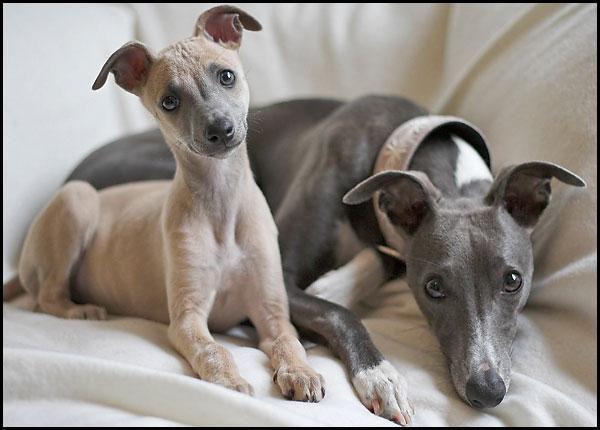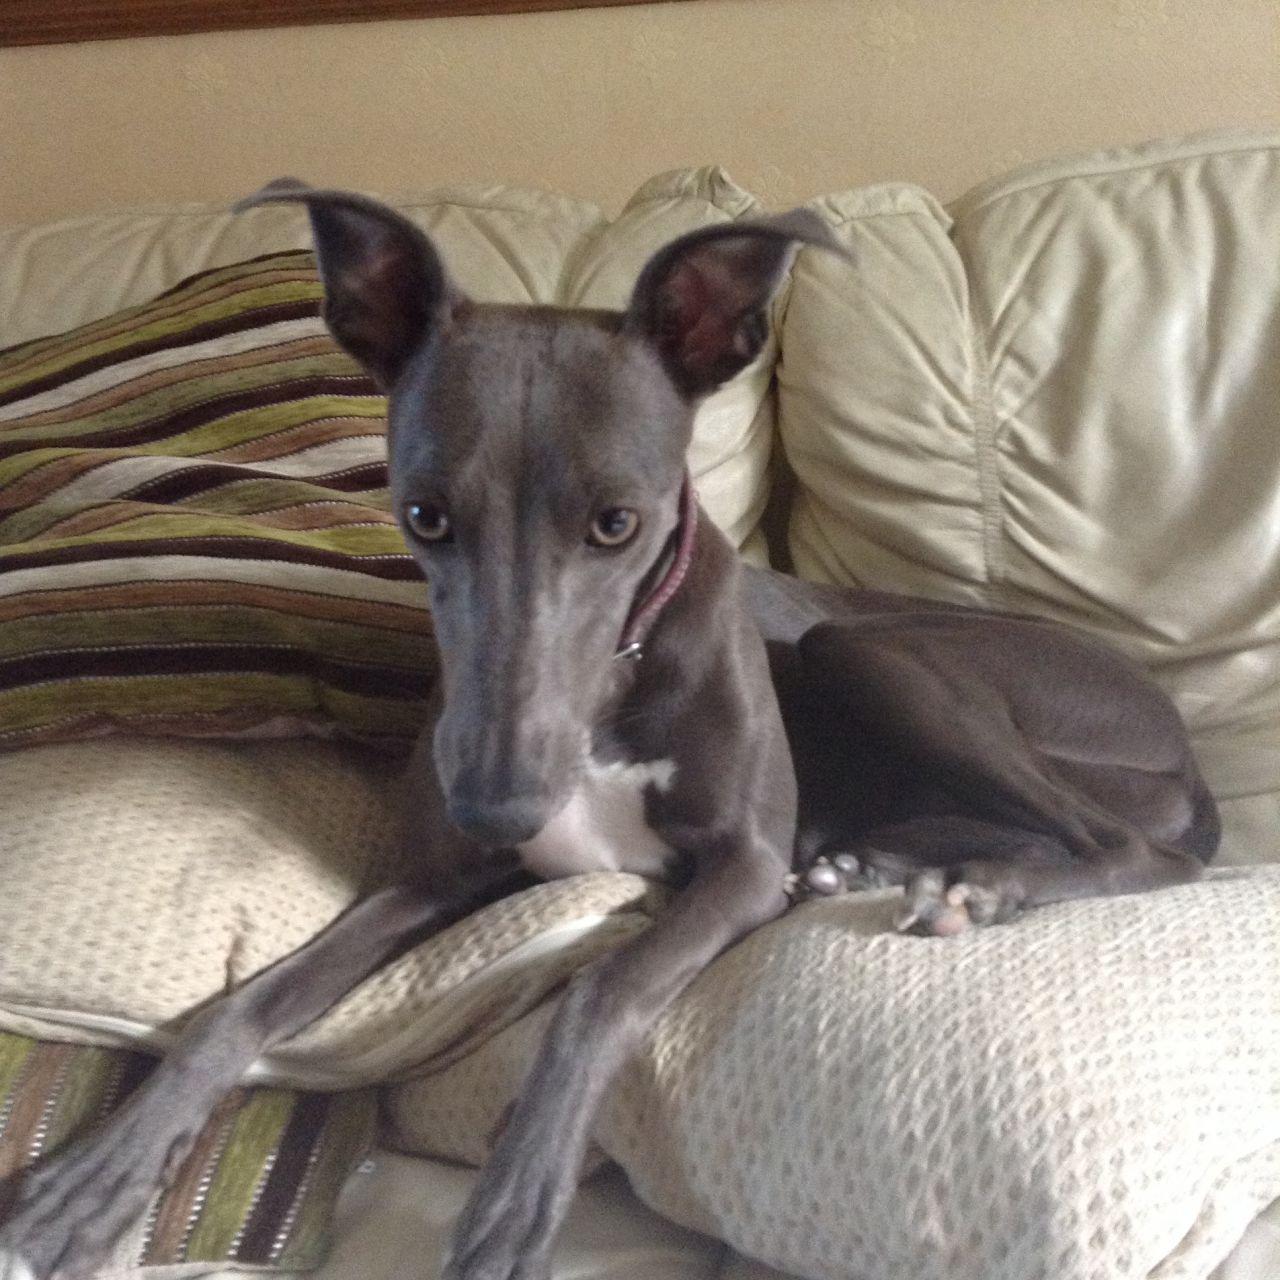The first image is the image on the left, the second image is the image on the right. Evaluate the accuracy of this statement regarding the images: "Three hounds with heads turned in the same direction, pose standing next to one another, in ascending size order.". Is it true? Answer yes or no. No. The first image is the image on the left, the second image is the image on the right. Evaluate the accuracy of this statement regarding the images: "There is exactly three dogs in the right image.". Is it true? Answer yes or no. No. 